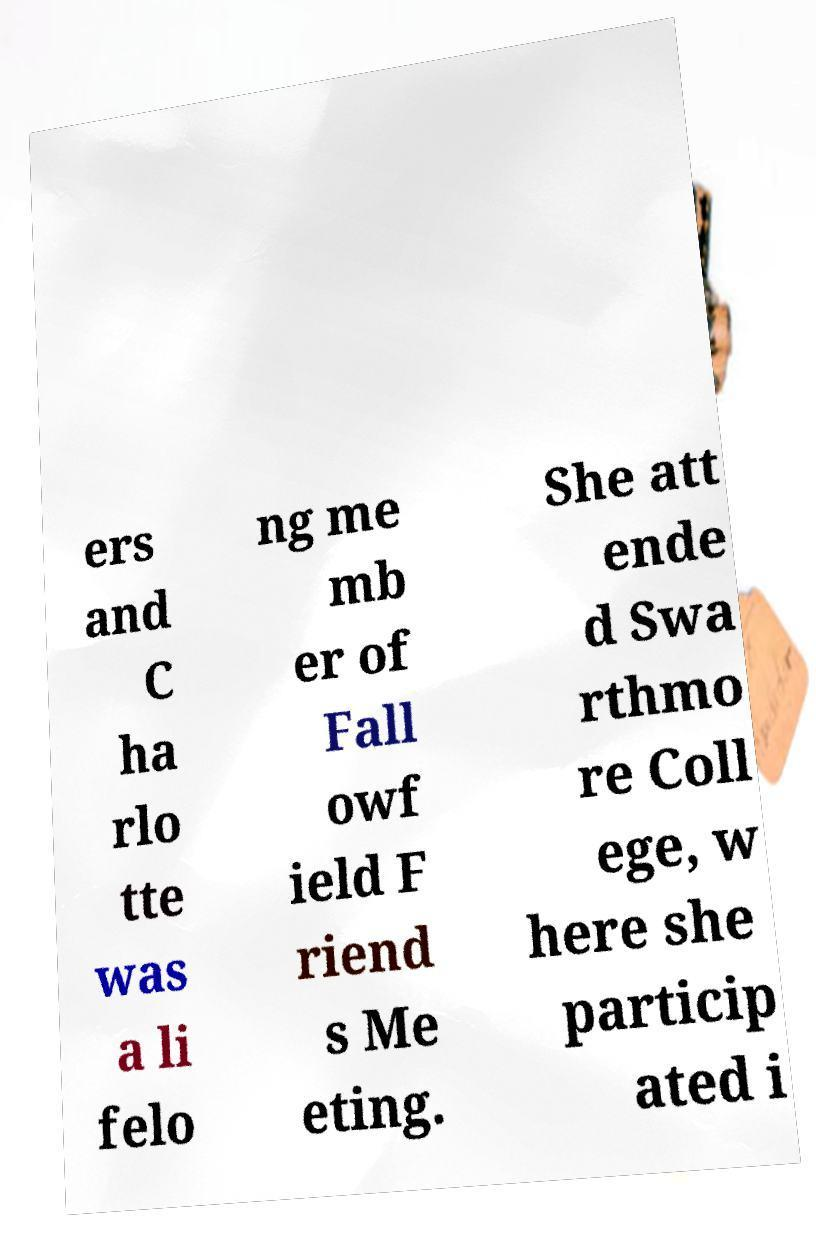For documentation purposes, I need the text within this image transcribed. Could you provide that? ers and C ha rlo tte was a li felo ng me mb er of Fall owf ield F riend s Me eting. She att ende d Swa rthmo re Coll ege, w here she particip ated i 